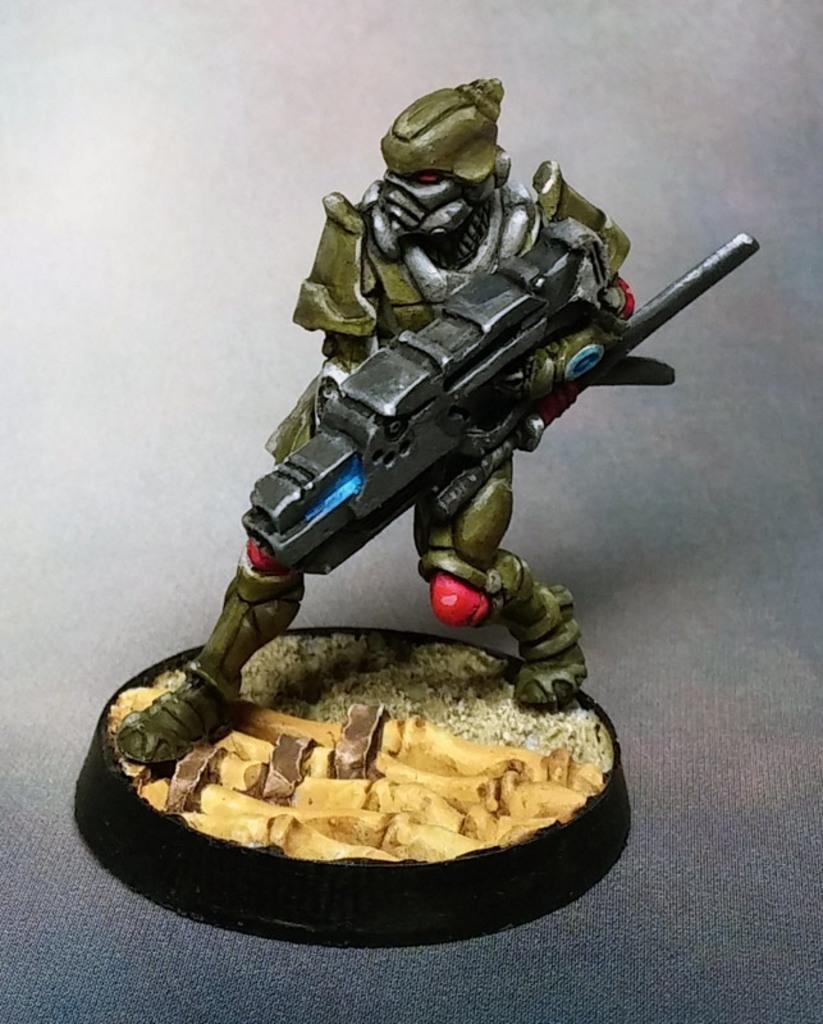Could you give a brief overview of what you see in this image? In the center of the image a toy robot is there. 